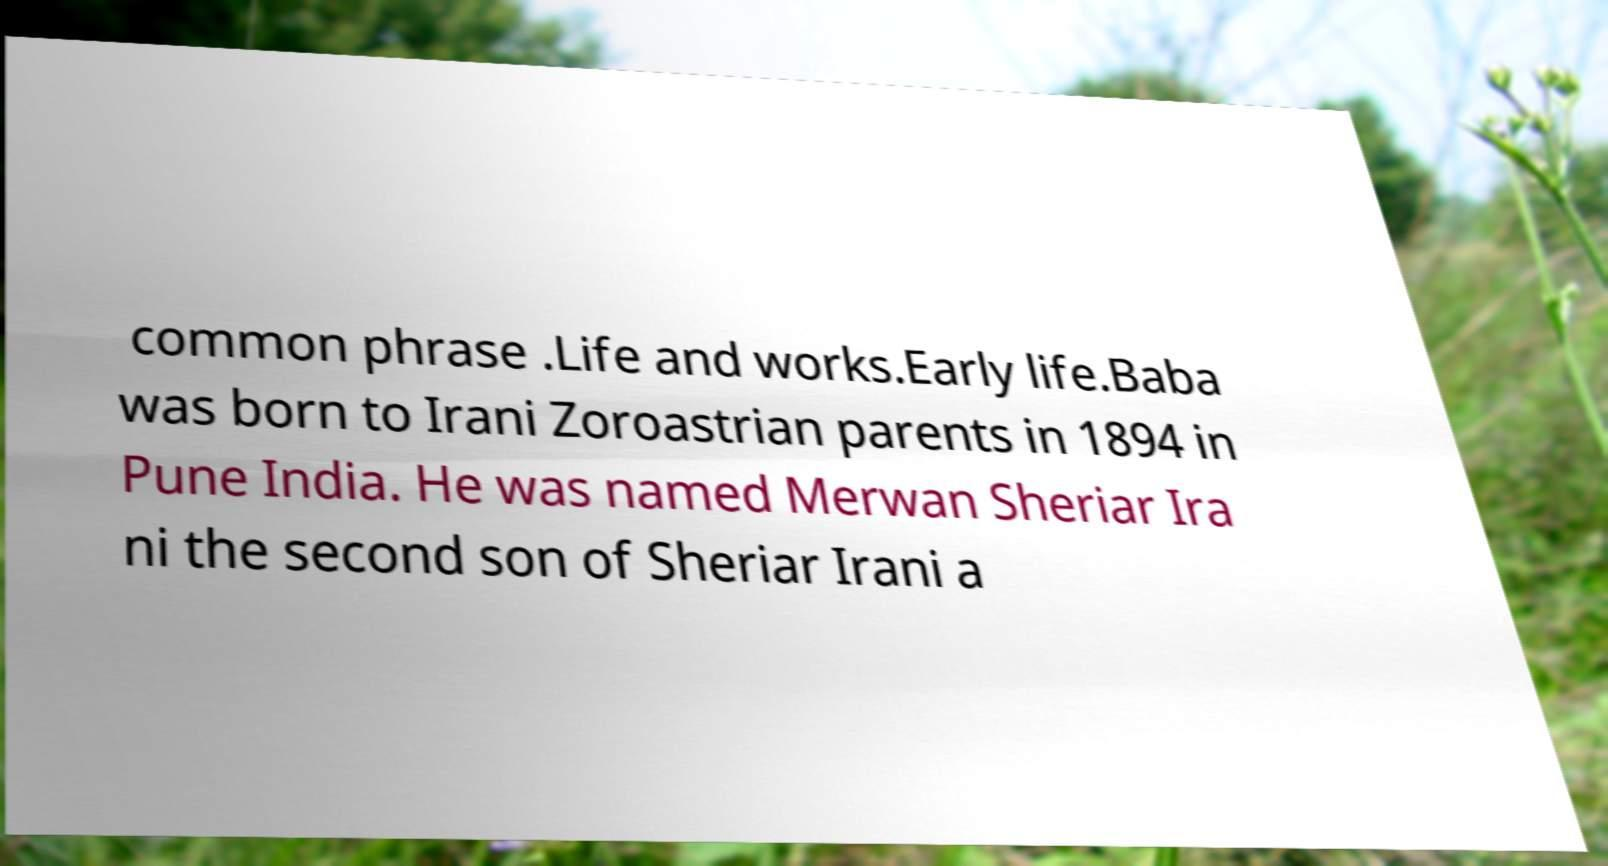For documentation purposes, I need the text within this image transcribed. Could you provide that? common phrase .Life and works.Early life.Baba was born to Irani Zoroastrian parents in 1894 in Pune India. He was named Merwan Sheriar Ira ni the second son of Sheriar Irani a 